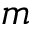<formula> <loc_0><loc_0><loc_500><loc_500>m</formula> 